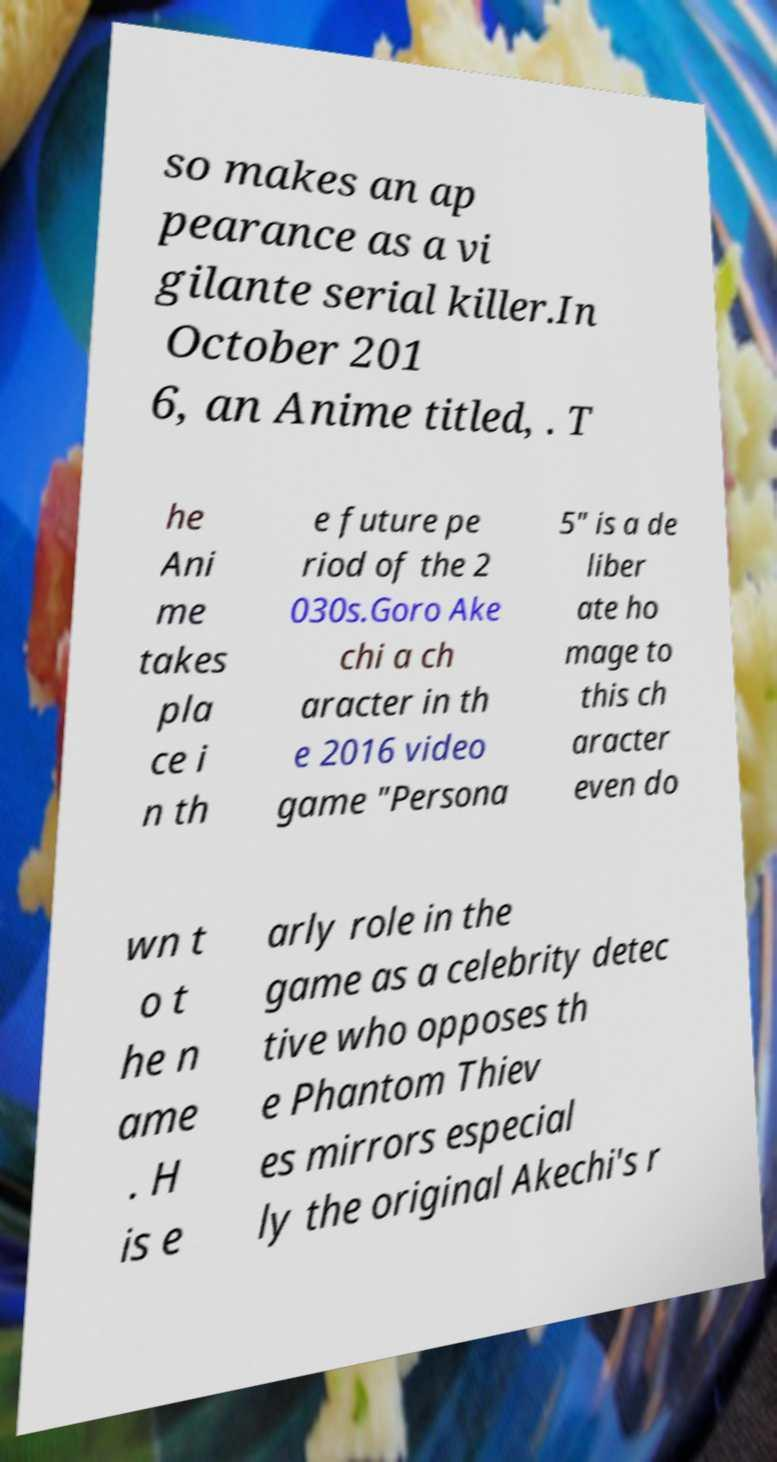Please read and relay the text visible in this image. What does it say? so makes an ap pearance as a vi gilante serial killer.In October 201 6, an Anime titled, . T he Ani me takes pla ce i n th e future pe riod of the 2 030s.Goro Ake chi a ch aracter in th e 2016 video game "Persona 5" is a de liber ate ho mage to this ch aracter even do wn t o t he n ame . H is e arly role in the game as a celebrity detec tive who opposes th e Phantom Thiev es mirrors especial ly the original Akechi's r 